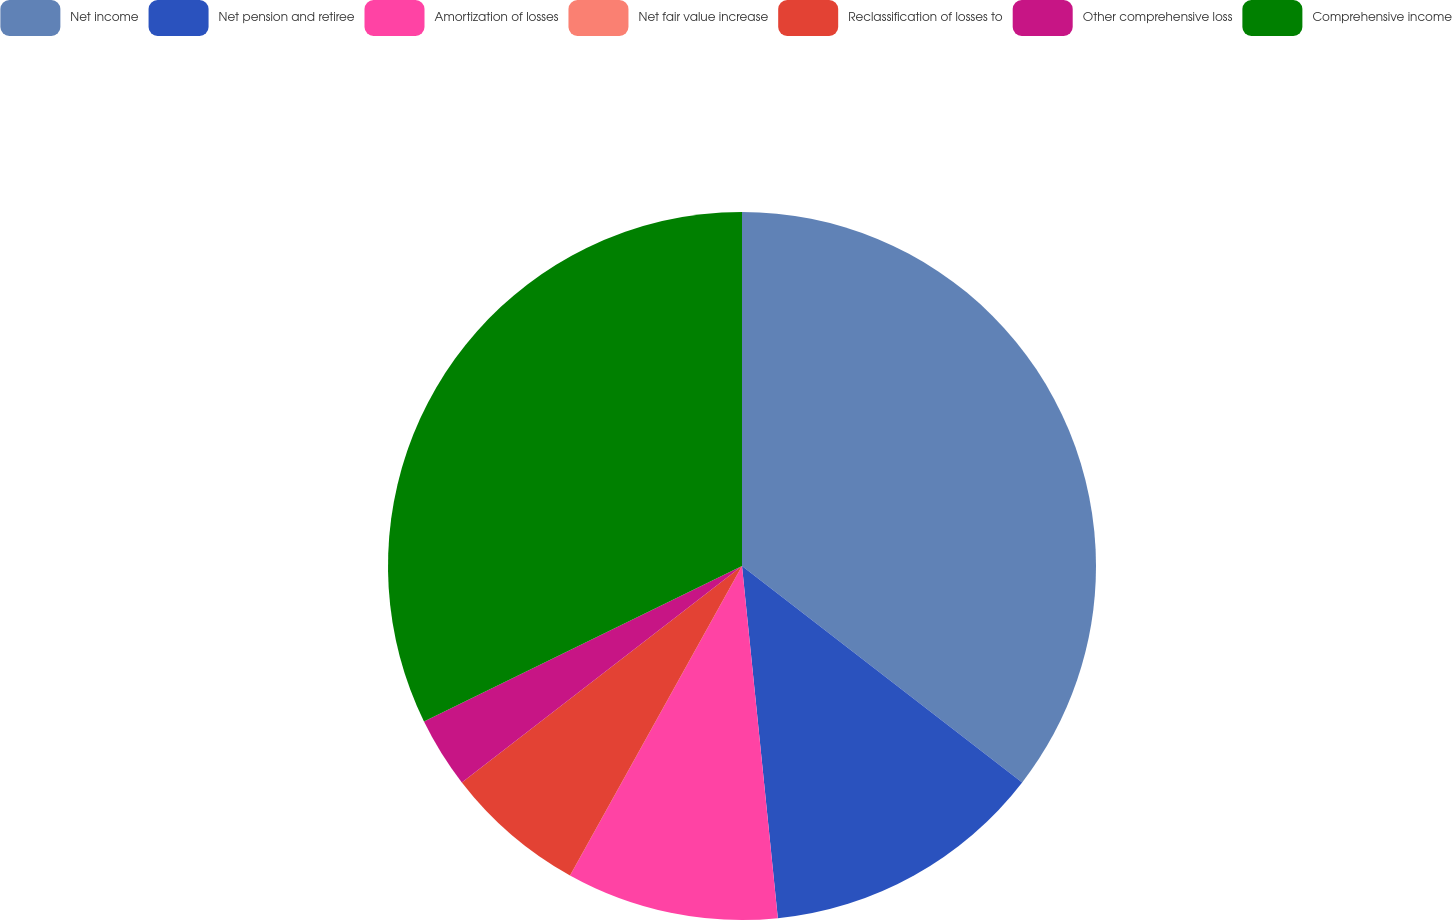<chart> <loc_0><loc_0><loc_500><loc_500><pie_chart><fcel>Net income<fcel>Net pension and retiree<fcel>Amortization of losses<fcel>Net fair value increase<fcel>Reclassification of losses to<fcel>Other comprehensive loss<fcel>Comprehensive income<nl><fcel>35.47%<fcel>12.92%<fcel>9.69%<fcel>0.0%<fcel>6.46%<fcel>3.23%<fcel>32.24%<nl></chart> 